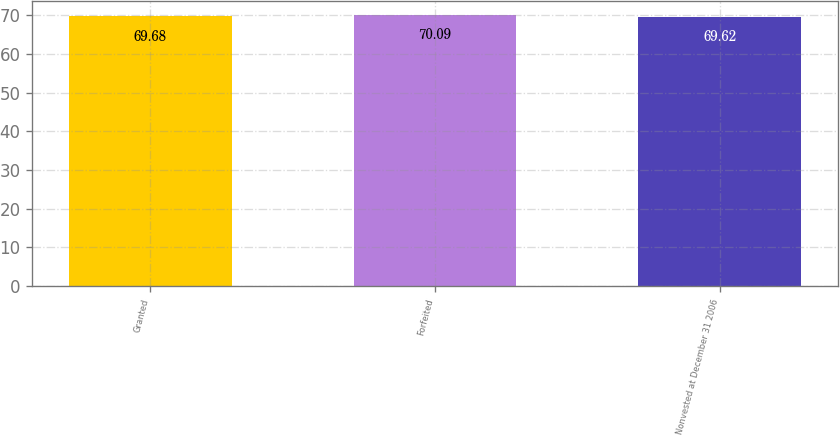Convert chart to OTSL. <chart><loc_0><loc_0><loc_500><loc_500><bar_chart><fcel>Granted<fcel>Forfeited<fcel>Nonvested at December 31 2006<nl><fcel>69.68<fcel>70.09<fcel>69.62<nl></chart> 